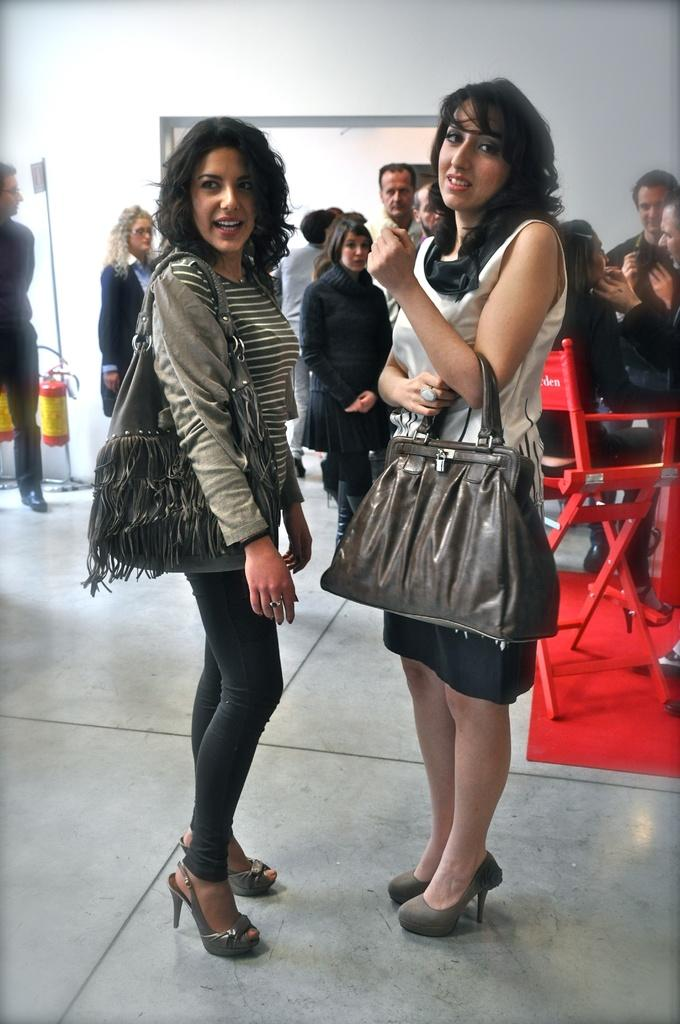How many people are in the group shown in the image? There is a group of persons in the image. What is the position of the persons in the image? The persons are standing on the floor. Can you identify the gender of any of the persons in the group? Yes, two women are standing in the group. What are the women wearing in the image? The women are wearing handbags. Is there any person sitting in the group? Yes, there is a person sitting in the group. What is visible in the background of the image? There is a wall visible in the image. What type of receipt can be seen in the hands of the person sitting in the group? There is no receipt visible in the hands of the person sitting in the group. 